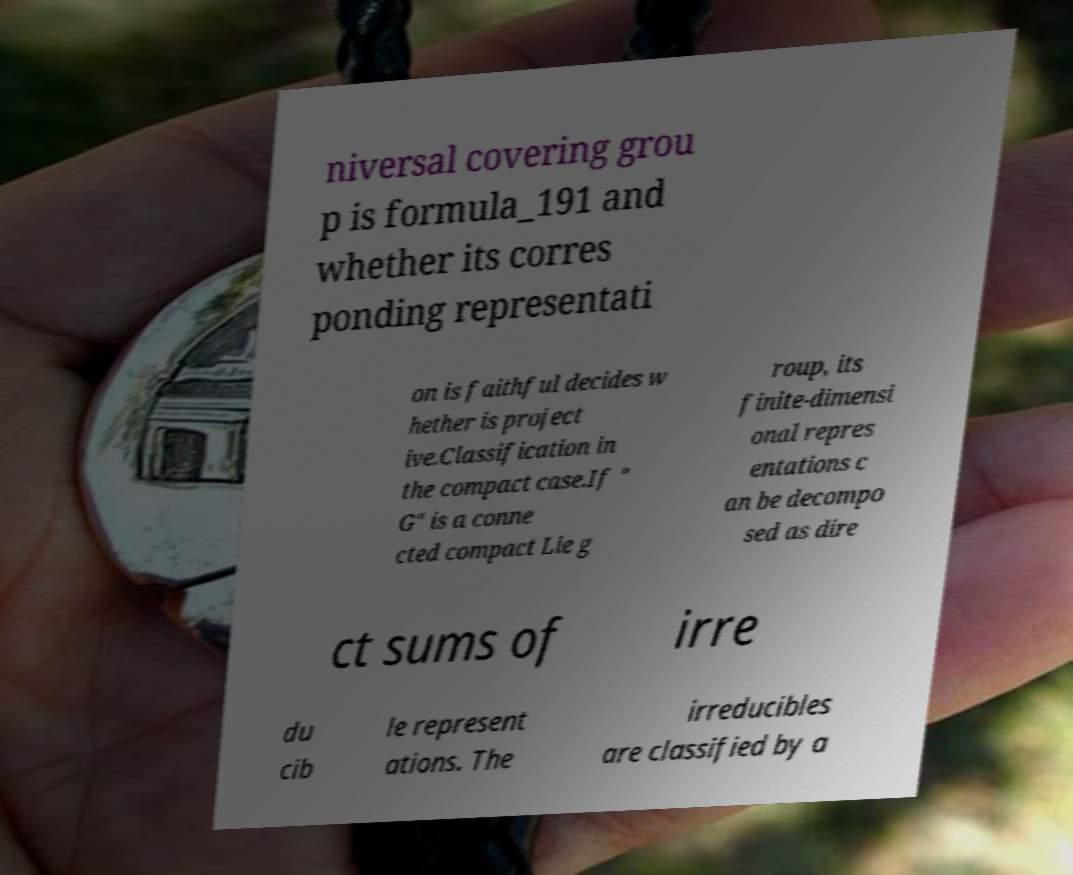What messages or text are displayed in this image? I need them in a readable, typed format. niversal covering grou p is formula_191 and whether its corres ponding representati on is faithful decides w hether is project ive.Classification in the compact case.If " G" is a conne cted compact Lie g roup, its finite-dimensi onal repres entations c an be decompo sed as dire ct sums of irre du cib le represent ations. The irreducibles are classified by a 